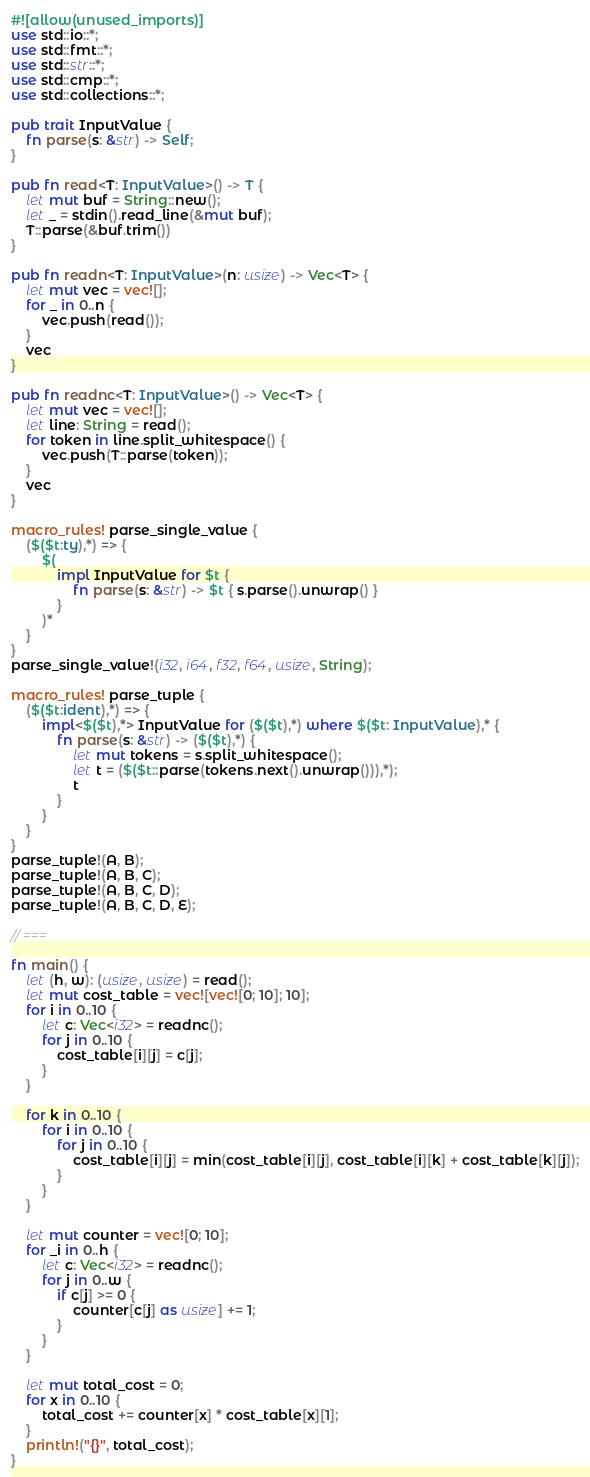<code> <loc_0><loc_0><loc_500><loc_500><_Rust_>#![allow(unused_imports)]
use std::io::*;
use std::fmt::*;
use std::str::*;
use std::cmp::*;
use std::collections::*;

pub trait InputValue {
    fn parse(s: &str) -> Self;
}

pub fn read<T: InputValue>() -> T {
    let mut buf = String::new();
    let _ = stdin().read_line(&mut buf);
    T::parse(&buf.trim())
}

pub fn readn<T: InputValue>(n: usize) -> Vec<T> {
    let mut vec = vec![];
    for _ in 0..n {
        vec.push(read());
    }
    vec
}

pub fn readnc<T: InputValue>() -> Vec<T> {
    let mut vec = vec![];
    let line: String = read();
    for token in line.split_whitespace() {
        vec.push(T::parse(token));
    }
    vec
}

macro_rules! parse_single_value {
    ($($t:ty),*) => {
        $(
            impl InputValue for $t {
                fn parse(s: &str) -> $t { s.parse().unwrap() }
            }
        )*
	}
}
parse_single_value!(i32, i64, f32, f64, usize, String);

macro_rules! parse_tuple {
	($($t:ident),*) => {
		impl<$($t),*> InputValue for ($($t),*) where $($t: InputValue),* {
			fn parse(s: &str) -> ($($t),*) {
				let mut tokens = s.split_whitespace();
				let t = ($($t::parse(tokens.next().unwrap())),*);
				t
			}
		}
	}
}
parse_tuple!(A, B);
parse_tuple!(A, B, C);
parse_tuple!(A, B, C, D);
parse_tuple!(A, B, C, D, E);

// ===

fn main() {
    let (h, w): (usize, usize) = read();
    let mut cost_table = vec![vec![0; 10]; 10];
    for i in 0..10 {
        let c: Vec<i32> = readnc();
        for j in 0..10 {
            cost_table[i][j] = c[j];
        }
    }

    for k in 0..10 {
        for i in 0..10 {
            for j in 0..10 {
                cost_table[i][j] = min(cost_table[i][j], cost_table[i][k] + cost_table[k][j]);
            }
        }
    }

    let mut counter = vec![0; 10];
    for _i in 0..h {
        let c: Vec<i32> = readnc();
        for j in 0..w {
            if c[j] >= 0 {
                counter[c[j] as usize] += 1;
            }
        }
    }

    let mut total_cost = 0;
    for x in 0..10 {
        total_cost += counter[x] * cost_table[x][1];
    }
    println!("{}", total_cost);
}
</code> 